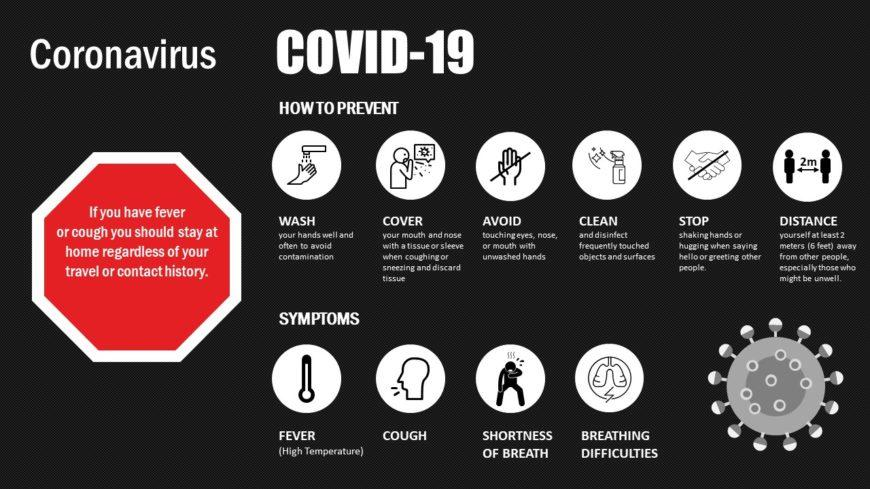Identify some key points in this picture. COVID-19 can cause a variety of symptoms in addition to fever and difficulty breathing, including a persistent cough and shortness of breath. 